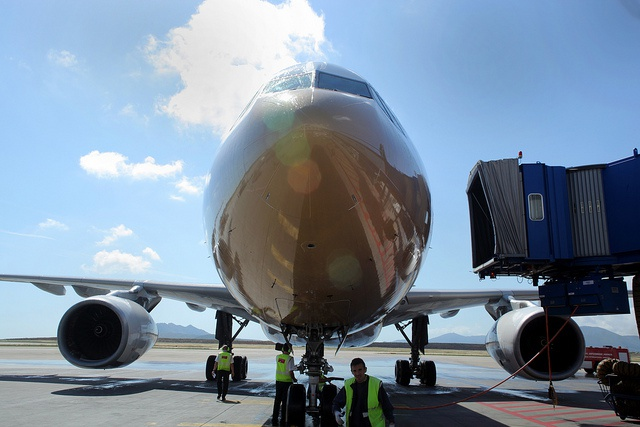Describe the objects in this image and their specific colors. I can see airplane in lightblue, black, gray, and maroon tones, people in lightblue, black, darkgreen, and green tones, people in lightblue, black, gray, darkgreen, and green tones, truck in lightblue, black, gray, and maroon tones, and people in lightblue, black, gray, darkgreen, and green tones in this image. 